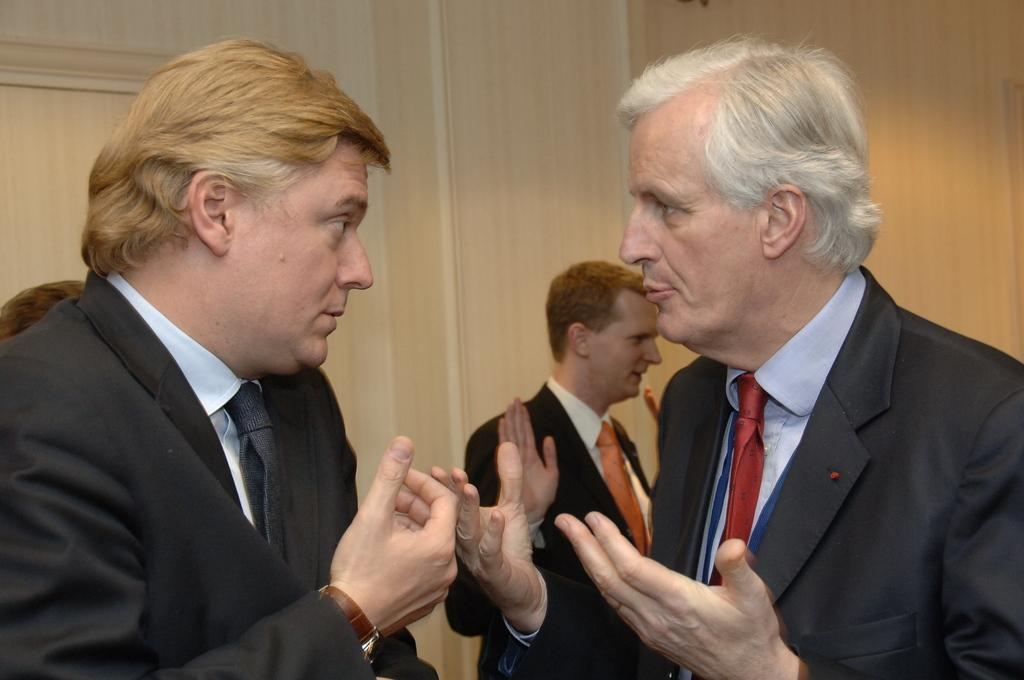What is the main subject of the image? There is a man standing in the image. Can you describe the background of the image? There are walls in the background of the image. What type of insurance policy is the man holding in the image? There is no indication in the image that the man is holding any insurance policy in the image. 